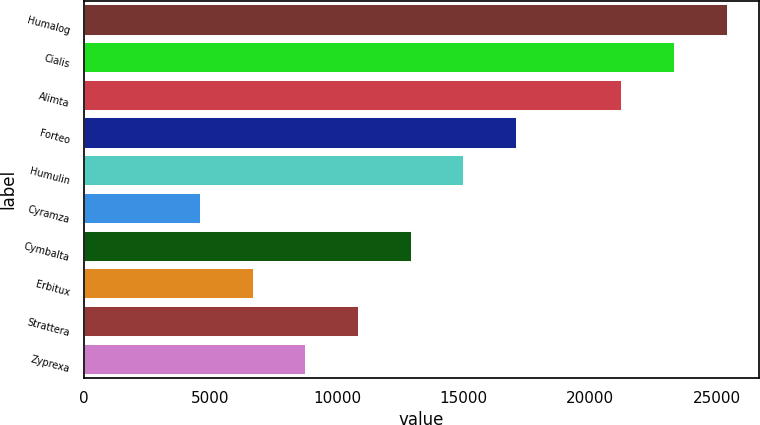Convert chart. <chart><loc_0><loc_0><loc_500><loc_500><bar_chart><fcel>Humalog<fcel>Cialis<fcel>Alimta<fcel>Forteo<fcel>Humulin<fcel>Cyramza<fcel>Cymbalta<fcel>Erbitux<fcel>Strattera<fcel>Zyprexa<nl><fcel>25379.2<fcel>23300.7<fcel>21222.1<fcel>17065<fcel>14986.5<fcel>4593.7<fcel>12907.9<fcel>6672.25<fcel>10829.4<fcel>8750.8<nl></chart> 